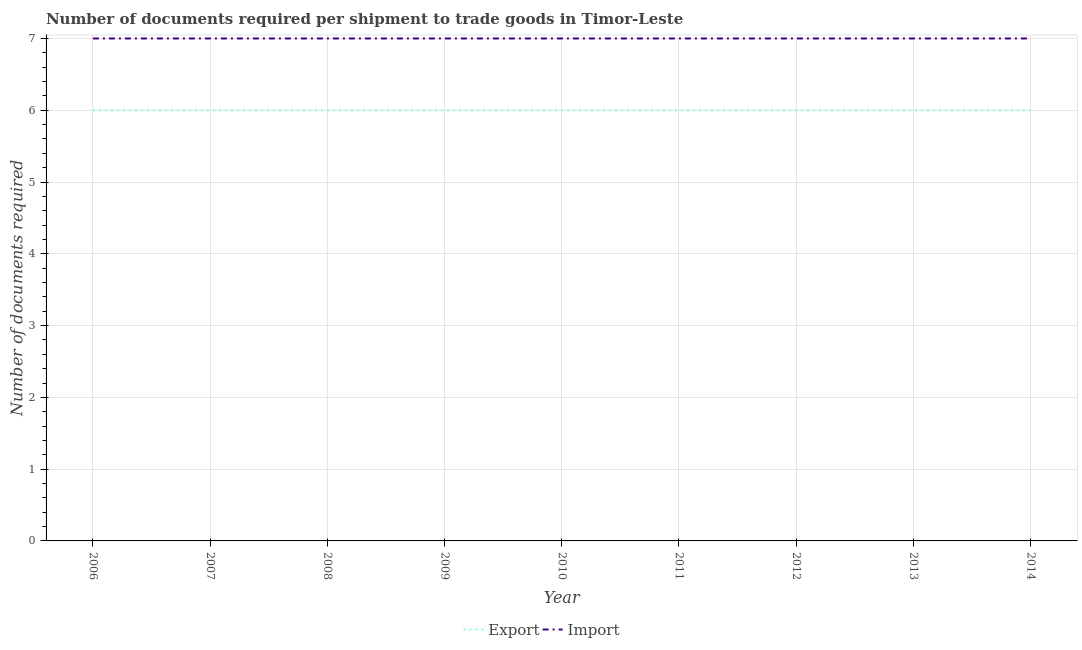What is the number of documents required to import goods in 2008?
Give a very brief answer. 7. Across all years, what is the minimum number of documents required to import goods?
Ensure brevity in your answer.  7. What is the total number of documents required to export goods in the graph?
Give a very brief answer. 54. What is the difference between the number of documents required to export goods in 2012 and the number of documents required to import goods in 2011?
Provide a succinct answer. -1. What is the average number of documents required to export goods per year?
Ensure brevity in your answer.  6. In the year 2010, what is the difference between the number of documents required to import goods and number of documents required to export goods?
Give a very brief answer. 1. In how many years, is the number of documents required to export goods greater than 2.8?
Keep it short and to the point. 9. What is the ratio of the number of documents required to export goods in 2008 to that in 2014?
Offer a terse response. 1. What is the difference between the highest and the lowest number of documents required to import goods?
Provide a succinct answer. 0. In how many years, is the number of documents required to export goods greater than the average number of documents required to export goods taken over all years?
Provide a succinct answer. 0. What is the difference between two consecutive major ticks on the Y-axis?
Your response must be concise. 1. How are the legend labels stacked?
Your response must be concise. Horizontal. What is the title of the graph?
Your answer should be very brief. Number of documents required per shipment to trade goods in Timor-Leste. What is the label or title of the X-axis?
Your response must be concise. Year. What is the label or title of the Y-axis?
Your response must be concise. Number of documents required. What is the Number of documents required of Export in 2006?
Provide a succinct answer. 6. What is the Number of documents required in Import in 2007?
Your answer should be compact. 7. What is the Number of documents required in Import in 2008?
Provide a succinct answer. 7. What is the Number of documents required of Export in 2010?
Offer a terse response. 6. What is the Number of documents required of Import in 2011?
Provide a short and direct response. 7. What is the Number of documents required of Export in 2012?
Offer a very short reply. 6. What is the Number of documents required of Import in 2012?
Ensure brevity in your answer.  7. What is the Number of documents required of Import in 2014?
Provide a short and direct response. 7. Across all years, what is the maximum Number of documents required of Import?
Your answer should be very brief. 7. What is the total Number of documents required of Import in the graph?
Offer a terse response. 63. What is the difference between the Number of documents required in Export in 2006 and that in 2007?
Give a very brief answer. 0. What is the difference between the Number of documents required in Import in 2006 and that in 2007?
Your answer should be compact. 0. What is the difference between the Number of documents required of Export in 2006 and that in 2008?
Offer a terse response. 0. What is the difference between the Number of documents required of Import in 2006 and that in 2014?
Your response must be concise. 0. What is the difference between the Number of documents required in Export in 2007 and that in 2008?
Your response must be concise. 0. What is the difference between the Number of documents required of Import in 2007 and that in 2008?
Offer a terse response. 0. What is the difference between the Number of documents required of Import in 2007 and that in 2009?
Give a very brief answer. 0. What is the difference between the Number of documents required in Import in 2007 and that in 2010?
Your answer should be compact. 0. What is the difference between the Number of documents required in Export in 2007 and that in 2011?
Offer a very short reply. 0. What is the difference between the Number of documents required in Import in 2007 and that in 2011?
Provide a succinct answer. 0. What is the difference between the Number of documents required of Export in 2007 and that in 2012?
Your answer should be very brief. 0. What is the difference between the Number of documents required in Import in 2007 and that in 2013?
Your answer should be compact. 0. What is the difference between the Number of documents required of Import in 2008 and that in 2010?
Offer a very short reply. 0. What is the difference between the Number of documents required in Import in 2008 and that in 2011?
Provide a succinct answer. 0. What is the difference between the Number of documents required of Import in 2008 and that in 2012?
Your answer should be compact. 0. What is the difference between the Number of documents required in Export in 2008 and that in 2013?
Your response must be concise. 0. What is the difference between the Number of documents required in Export in 2008 and that in 2014?
Keep it short and to the point. 0. What is the difference between the Number of documents required in Import in 2008 and that in 2014?
Your answer should be compact. 0. What is the difference between the Number of documents required of Export in 2009 and that in 2010?
Ensure brevity in your answer.  0. What is the difference between the Number of documents required of Import in 2009 and that in 2010?
Your answer should be compact. 0. What is the difference between the Number of documents required of Export in 2009 and that in 2011?
Provide a short and direct response. 0. What is the difference between the Number of documents required of Export in 2009 and that in 2012?
Offer a terse response. 0. What is the difference between the Number of documents required of Import in 2009 and that in 2012?
Provide a succinct answer. 0. What is the difference between the Number of documents required of Export in 2009 and that in 2013?
Your answer should be compact. 0. What is the difference between the Number of documents required of Export in 2010 and that in 2011?
Make the answer very short. 0. What is the difference between the Number of documents required of Import in 2010 and that in 2011?
Provide a succinct answer. 0. What is the difference between the Number of documents required of Export in 2010 and that in 2012?
Offer a very short reply. 0. What is the difference between the Number of documents required in Import in 2010 and that in 2012?
Your answer should be very brief. 0. What is the difference between the Number of documents required in Export in 2010 and that in 2013?
Ensure brevity in your answer.  0. What is the difference between the Number of documents required in Export in 2010 and that in 2014?
Keep it short and to the point. 0. What is the difference between the Number of documents required of Import in 2010 and that in 2014?
Give a very brief answer. 0. What is the difference between the Number of documents required in Import in 2011 and that in 2012?
Your response must be concise. 0. What is the difference between the Number of documents required of Export in 2011 and that in 2013?
Keep it short and to the point. 0. What is the difference between the Number of documents required of Export in 2011 and that in 2014?
Give a very brief answer. 0. What is the difference between the Number of documents required of Import in 2011 and that in 2014?
Offer a terse response. 0. What is the difference between the Number of documents required of Import in 2012 and that in 2013?
Your response must be concise. 0. What is the difference between the Number of documents required of Import in 2012 and that in 2014?
Provide a succinct answer. 0. What is the difference between the Number of documents required in Import in 2013 and that in 2014?
Your answer should be very brief. 0. What is the difference between the Number of documents required in Export in 2006 and the Number of documents required in Import in 2008?
Your response must be concise. -1. What is the difference between the Number of documents required in Export in 2006 and the Number of documents required in Import in 2009?
Give a very brief answer. -1. What is the difference between the Number of documents required in Export in 2006 and the Number of documents required in Import in 2010?
Ensure brevity in your answer.  -1. What is the difference between the Number of documents required in Export in 2006 and the Number of documents required in Import in 2011?
Make the answer very short. -1. What is the difference between the Number of documents required in Export in 2006 and the Number of documents required in Import in 2013?
Provide a succinct answer. -1. What is the difference between the Number of documents required in Export in 2006 and the Number of documents required in Import in 2014?
Make the answer very short. -1. What is the difference between the Number of documents required of Export in 2007 and the Number of documents required of Import in 2008?
Your answer should be compact. -1. What is the difference between the Number of documents required of Export in 2007 and the Number of documents required of Import in 2009?
Your answer should be very brief. -1. What is the difference between the Number of documents required of Export in 2007 and the Number of documents required of Import in 2010?
Ensure brevity in your answer.  -1. What is the difference between the Number of documents required in Export in 2007 and the Number of documents required in Import in 2013?
Your answer should be very brief. -1. What is the difference between the Number of documents required in Export in 2007 and the Number of documents required in Import in 2014?
Make the answer very short. -1. What is the difference between the Number of documents required of Export in 2008 and the Number of documents required of Import in 2009?
Keep it short and to the point. -1. What is the difference between the Number of documents required of Export in 2008 and the Number of documents required of Import in 2010?
Your response must be concise. -1. What is the difference between the Number of documents required of Export in 2008 and the Number of documents required of Import in 2012?
Your answer should be very brief. -1. What is the difference between the Number of documents required in Export in 2008 and the Number of documents required in Import in 2013?
Give a very brief answer. -1. What is the difference between the Number of documents required of Export in 2008 and the Number of documents required of Import in 2014?
Your answer should be compact. -1. What is the difference between the Number of documents required of Export in 2009 and the Number of documents required of Import in 2010?
Your answer should be compact. -1. What is the difference between the Number of documents required in Export in 2009 and the Number of documents required in Import in 2013?
Keep it short and to the point. -1. What is the difference between the Number of documents required of Export in 2010 and the Number of documents required of Import in 2012?
Keep it short and to the point. -1. What is the difference between the Number of documents required in Export in 2011 and the Number of documents required in Import in 2012?
Your response must be concise. -1. What is the difference between the Number of documents required of Export in 2011 and the Number of documents required of Import in 2013?
Give a very brief answer. -1. What is the difference between the Number of documents required of Export in 2011 and the Number of documents required of Import in 2014?
Offer a very short reply. -1. What is the difference between the Number of documents required of Export in 2012 and the Number of documents required of Import in 2013?
Provide a succinct answer. -1. What is the difference between the Number of documents required in Export in 2012 and the Number of documents required in Import in 2014?
Ensure brevity in your answer.  -1. In the year 2007, what is the difference between the Number of documents required in Export and Number of documents required in Import?
Make the answer very short. -1. In the year 2011, what is the difference between the Number of documents required in Export and Number of documents required in Import?
Your answer should be compact. -1. In the year 2013, what is the difference between the Number of documents required of Export and Number of documents required of Import?
Your answer should be compact. -1. What is the ratio of the Number of documents required in Export in 2006 to that in 2008?
Make the answer very short. 1. What is the ratio of the Number of documents required in Import in 2006 to that in 2009?
Provide a short and direct response. 1. What is the ratio of the Number of documents required in Import in 2006 to that in 2010?
Give a very brief answer. 1. What is the ratio of the Number of documents required of Import in 2006 to that in 2012?
Offer a very short reply. 1. What is the ratio of the Number of documents required in Export in 2006 to that in 2013?
Ensure brevity in your answer.  1. What is the ratio of the Number of documents required of Import in 2006 to that in 2014?
Give a very brief answer. 1. What is the ratio of the Number of documents required in Export in 2007 to that in 2008?
Ensure brevity in your answer.  1. What is the ratio of the Number of documents required in Import in 2007 to that in 2008?
Offer a very short reply. 1. What is the ratio of the Number of documents required of Export in 2007 to that in 2009?
Provide a short and direct response. 1. What is the ratio of the Number of documents required of Import in 2007 to that in 2009?
Give a very brief answer. 1. What is the ratio of the Number of documents required in Export in 2007 to that in 2011?
Your answer should be compact. 1. What is the ratio of the Number of documents required of Import in 2007 to that in 2012?
Give a very brief answer. 1. What is the ratio of the Number of documents required in Export in 2007 to that in 2013?
Keep it short and to the point. 1. What is the ratio of the Number of documents required of Import in 2007 to that in 2013?
Your answer should be very brief. 1. What is the ratio of the Number of documents required of Export in 2007 to that in 2014?
Make the answer very short. 1. What is the ratio of the Number of documents required in Import in 2007 to that in 2014?
Your answer should be compact. 1. What is the ratio of the Number of documents required of Export in 2008 to that in 2009?
Keep it short and to the point. 1. What is the ratio of the Number of documents required in Import in 2008 to that in 2009?
Ensure brevity in your answer.  1. What is the ratio of the Number of documents required in Import in 2008 to that in 2010?
Your answer should be very brief. 1. What is the ratio of the Number of documents required of Export in 2008 to that in 2011?
Your answer should be very brief. 1. What is the ratio of the Number of documents required in Import in 2008 to that in 2012?
Keep it short and to the point. 1. What is the ratio of the Number of documents required of Import in 2008 to that in 2013?
Offer a very short reply. 1. What is the ratio of the Number of documents required in Export in 2008 to that in 2014?
Keep it short and to the point. 1. What is the ratio of the Number of documents required in Import in 2008 to that in 2014?
Offer a very short reply. 1. What is the ratio of the Number of documents required in Import in 2009 to that in 2010?
Provide a short and direct response. 1. What is the ratio of the Number of documents required in Export in 2009 to that in 2013?
Provide a short and direct response. 1. What is the ratio of the Number of documents required in Import in 2009 to that in 2014?
Your answer should be compact. 1. What is the ratio of the Number of documents required of Import in 2010 to that in 2012?
Make the answer very short. 1. What is the ratio of the Number of documents required of Import in 2010 to that in 2013?
Provide a short and direct response. 1. What is the ratio of the Number of documents required of Export in 2010 to that in 2014?
Ensure brevity in your answer.  1. What is the ratio of the Number of documents required in Import in 2010 to that in 2014?
Your answer should be compact. 1. What is the ratio of the Number of documents required in Export in 2011 to that in 2012?
Your response must be concise. 1. What is the ratio of the Number of documents required of Import in 2011 to that in 2012?
Give a very brief answer. 1. What is the ratio of the Number of documents required of Export in 2011 to that in 2014?
Keep it short and to the point. 1. What is the ratio of the Number of documents required of Import in 2011 to that in 2014?
Provide a short and direct response. 1. What is the ratio of the Number of documents required in Import in 2012 to that in 2013?
Offer a terse response. 1. What is the ratio of the Number of documents required of Export in 2012 to that in 2014?
Provide a short and direct response. 1. What is the ratio of the Number of documents required in Export in 2013 to that in 2014?
Provide a succinct answer. 1. What is the difference between the highest and the second highest Number of documents required of Export?
Ensure brevity in your answer.  0. What is the difference between the highest and the lowest Number of documents required in Export?
Ensure brevity in your answer.  0. What is the difference between the highest and the lowest Number of documents required in Import?
Offer a very short reply. 0. 